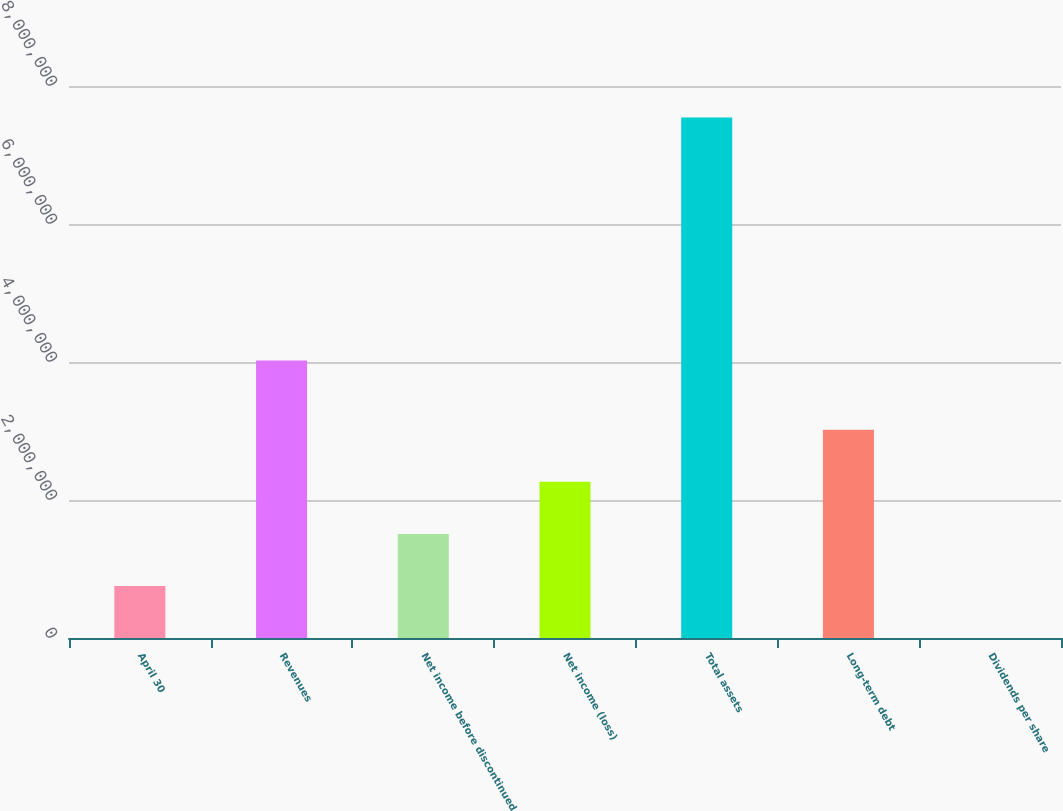Convert chart to OTSL. <chart><loc_0><loc_0><loc_500><loc_500><bar_chart><fcel>April 30<fcel>Revenues<fcel>Net income before discontinued<fcel>Net income (loss)<fcel>Total assets<fcel>Long-term debt<fcel>Dividends per share<nl><fcel>754405<fcel>4.02127e+06<fcel>1.50881e+06<fcel>2.26322e+06<fcel>7.54405e+06<fcel>3.01762e+06<fcel>0.53<nl></chart> 